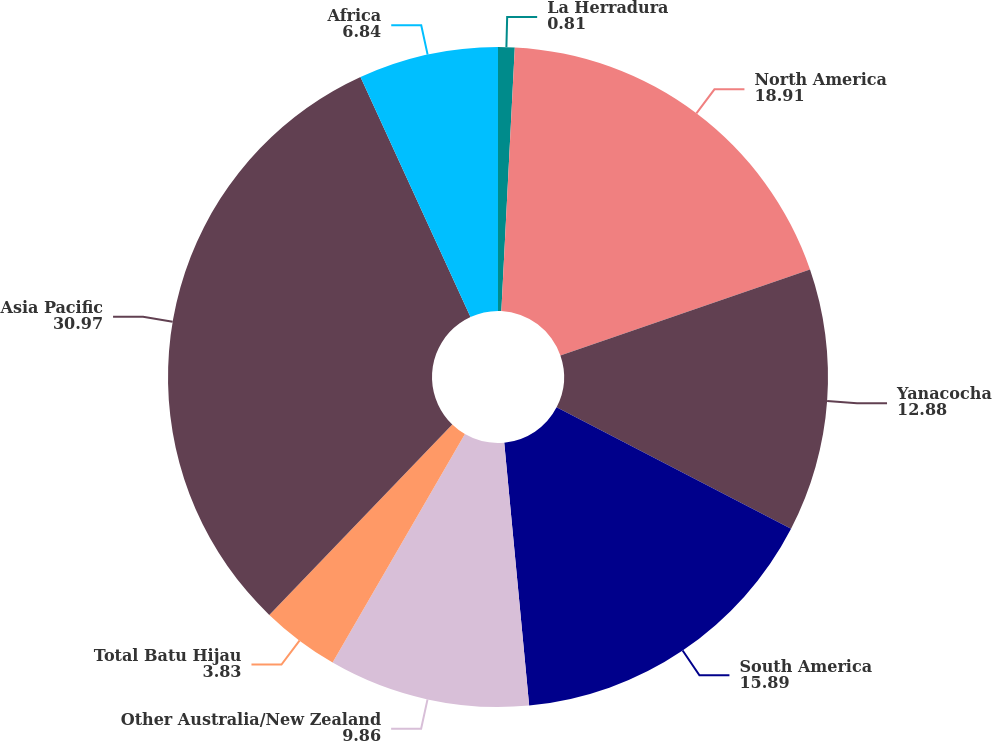<chart> <loc_0><loc_0><loc_500><loc_500><pie_chart><fcel>La Herradura<fcel>North America<fcel>Yanacocha<fcel>South America<fcel>Other Australia/New Zealand<fcel>Total Batu Hijau<fcel>Asia Pacific<fcel>Africa<nl><fcel>0.81%<fcel>18.91%<fcel>12.88%<fcel>15.89%<fcel>9.86%<fcel>3.83%<fcel>30.97%<fcel>6.84%<nl></chart> 